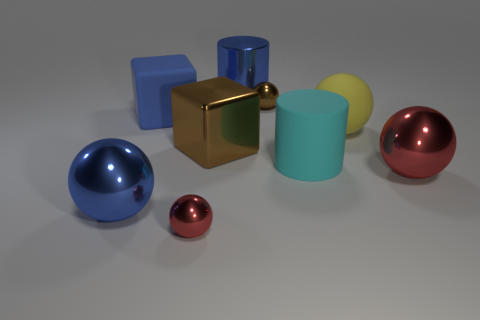Subtract all blue shiny spheres. How many spheres are left? 4 Subtract all brown blocks. How many blocks are left? 1 Subtract 2 cubes. How many cubes are left? 0 Subtract all cubes. How many objects are left? 7 Subtract all brown cylinders. Subtract all blue spheres. How many cylinders are left? 2 Subtract all green cylinders. How many cyan cubes are left? 0 Subtract all yellow matte spheres. Subtract all large blue rubber things. How many objects are left? 7 Add 6 big metal cylinders. How many big metal cylinders are left? 7 Add 1 small blue cubes. How many small blue cubes exist? 1 Subtract 0 red cylinders. How many objects are left? 9 